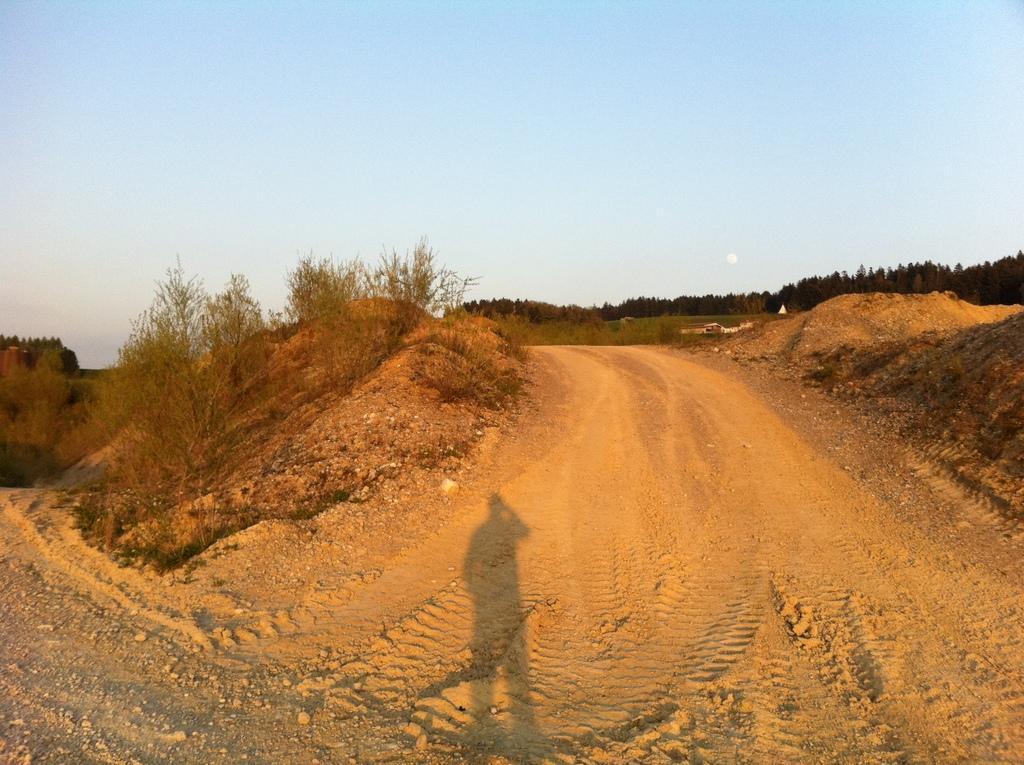What type of surface can be seen on the floor path in the image? There is a muddy floor path in the image. What can be observed on the muddy floor path? There is a shadow on the muddy floor path. What is visible in the background of the image? There are trees in the background of the image. What type of crown is being worn by the person in the image? There is no person or crown present in the image; it features a muddy floor path with a shadow and trees in the background. 